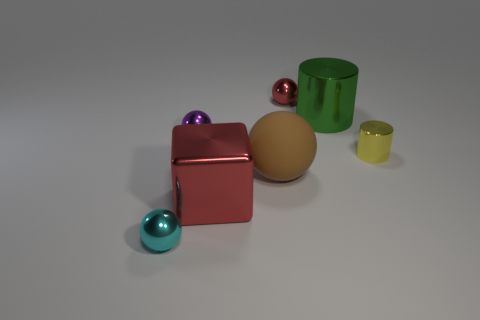There is a tiny metallic object that is in front of the tiny yellow object; is its color the same as the big metallic object behind the yellow metal object?
Provide a succinct answer. No. Are there more large green cylinders in front of the red sphere than small metal things?
Your response must be concise. No. What number of other things are there of the same color as the big ball?
Provide a succinct answer. 0. There is a red object behind the purple metallic object; is it the same size as the yellow cylinder?
Give a very brief answer. Yes. Are there any blocks that have the same size as the cyan metallic sphere?
Make the answer very short. No. There is a large shiny object that is on the left side of the red metal sphere; what color is it?
Provide a short and direct response. Red. There is a tiny metal thing that is both on the right side of the purple object and left of the yellow shiny cylinder; what shape is it?
Keep it short and to the point. Sphere. How many large things are the same shape as the small red object?
Offer a terse response. 1. What number of tiny metallic cylinders are there?
Make the answer very short. 1. How big is the metallic thing that is both behind the cyan sphere and in front of the small yellow metallic cylinder?
Offer a terse response. Large. 